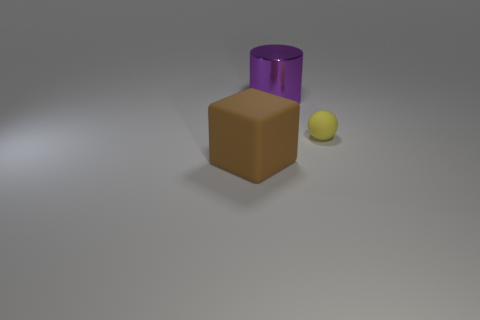Add 1 small cyan matte blocks. How many objects exist? 4 Subtract all cylinders. How many objects are left? 2 Add 1 matte blocks. How many matte blocks are left? 2 Add 3 gray matte blocks. How many gray matte blocks exist? 3 Subtract 1 yellow spheres. How many objects are left? 2 Subtract all tiny rubber balls. Subtract all big purple cylinders. How many objects are left? 1 